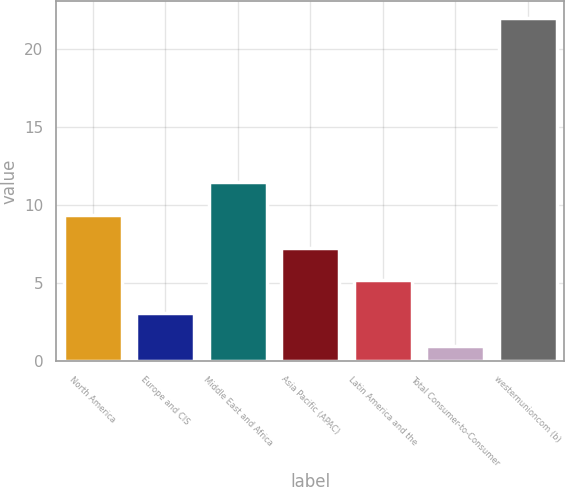Convert chart to OTSL. <chart><loc_0><loc_0><loc_500><loc_500><bar_chart><fcel>North America<fcel>Europe and CIS<fcel>Middle East and Africa<fcel>Asia Pacific (APAC)<fcel>Latin America and the<fcel>Total Consumer-to-Consumer<fcel>westernunioncom (b)<nl><fcel>9.4<fcel>3.1<fcel>11.5<fcel>7.3<fcel>5.2<fcel>1<fcel>22<nl></chart> 